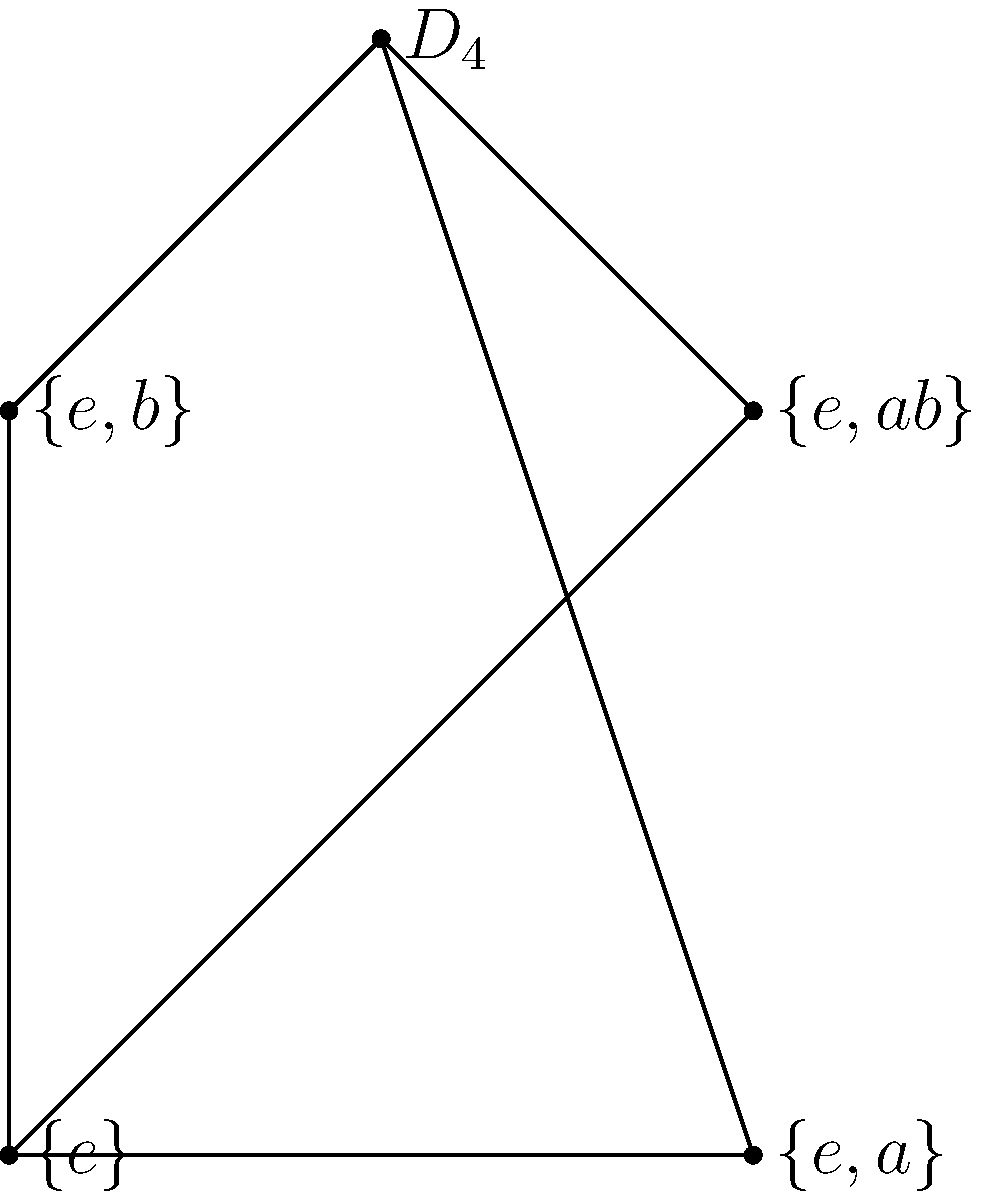Consider the subgroup lattice diagram of the dihedral group $D_4$. Which of the following statements is true about the subgroups $\{e,a\}$ and $\{e,b\}$?

A) They are conjugate subgroups
B) They form a direct product
C) Their intersection is $\{e\}$
D) Their union forms a subgroup of $D_4$ Let's analyze this step-by-step:

1) First, recall that $D_4$ is the symmetry group of a square, with 8 elements: rotations by 0°, 90°, 180°, 270°, and four reflections.

2) In the lattice diagram, $\{e,a\}$ and $\{e,b\}$ are both order-2 subgroups of $D_4$.

3) $\{e,a\}$ likely represents the subgroup generated by a 180° rotation, while $\{e,b\}$ likely represents a reflection.

4) These subgroups are not conjugate because they are fundamentally different types of symmetries (rotation vs. reflection).

5) They don't form a direct product because they are both subgroups of the same group, not separate groups being multiplied.

6) Their intersection is indeed $\{e\}$, as the only element they have in common is the identity.

7) Their union $\{e,a,b\}$ does not form a subgroup of $D_4$. If it did, it would contain $ab$, which would be another reflection, but the diagram shows $\{e,ab\}$ as a separate subgroup.

Therefore, the correct statement is that their intersection is $\{e\}$.
Answer: C 